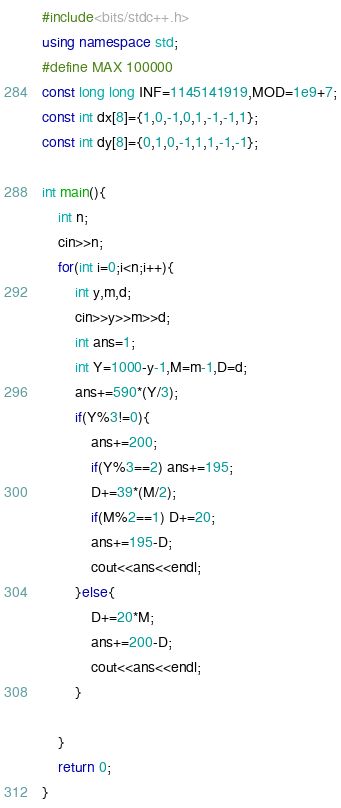<code> <loc_0><loc_0><loc_500><loc_500><_C++_>#include<bits/stdc++.h>
using namespace std;
#define MAX 100000
const long long INF=1145141919,MOD=1e9+7;
const int dx[8]={1,0,-1,0,1,-1,-1,1};
const int dy[8]={0,1,0,-1,1,1,-1,-1};

int main(){
    int n;
    cin>>n;
    for(int i=0;i<n;i++){
        int y,m,d;
        cin>>y>>m>>d;
        int ans=1;
        int Y=1000-y-1,M=m-1,D=d;
        ans+=590*(Y/3);
        if(Y%3!=0){
            ans+=200;
            if(Y%3==2) ans+=195;
            D+=39*(M/2);
            if(M%2==1) D+=20;
            ans+=195-D;
            cout<<ans<<endl;
        }else{
            D+=20*M;
            ans+=200-D;
            cout<<ans<<endl;
        }

    }
    return 0;
}

</code> 